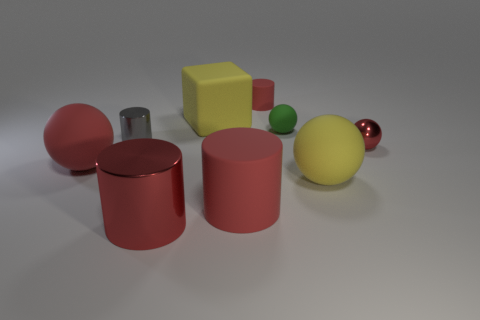Are there any small things?
Your answer should be very brief. Yes. There is a yellow object that is made of the same material as the block; what shape is it?
Make the answer very short. Sphere. There is a tiny green rubber object; is it the same shape as the yellow matte thing behind the gray thing?
Your answer should be very brief. No. What material is the yellow object behind the metallic cylinder behind the red metallic cylinder?
Your answer should be compact. Rubber. How many other things are the same shape as the gray thing?
Provide a succinct answer. 3. Is the shape of the tiny metallic thing on the left side of the tiny green matte object the same as the small thing in front of the gray metal thing?
Your answer should be very brief. No. Is there anything else that is the same material as the large red ball?
Offer a very short reply. Yes. What is the small gray cylinder made of?
Offer a very short reply. Metal. What is the material of the sphere that is behind the gray cylinder?
Make the answer very short. Rubber. Is there any other thing of the same color as the big block?
Make the answer very short. Yes. 